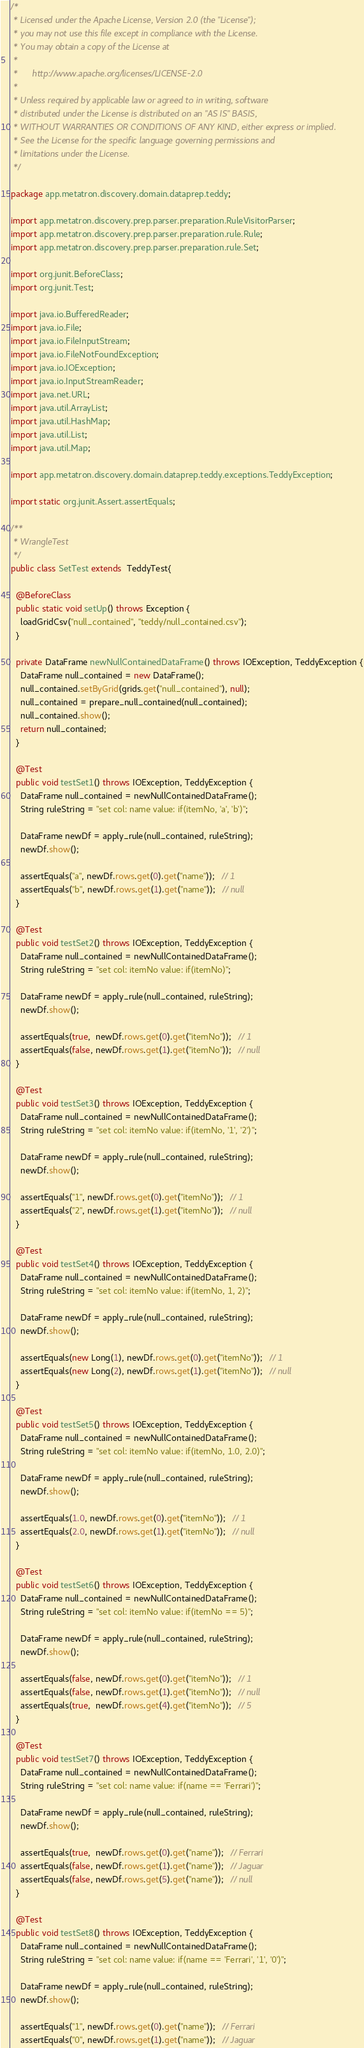Convert code to text. <code><loc_0><loc_0><loc_500><loc_500><_Java_>/*
 * Licensed under the Apache License, Version 2.0 (the "License");
 * you may not use this file except in compliance with the License.
 * You may obtain a copy of the License at
 *
 *      http://www.apache.org/licenses/LICENSE-2.0
 *
 * Unless required by applicable law or agreed to in writing, software
 * distributed under the License is distributed on an "AS IS" BASIS,
 * WITHOUT WARRANTIES OR CONDITIONS OF ANY KIND, either express or implied.
 * See the License for the specific language governing permissions and
 * limitations under the License.
 */

package app.metatron.discovery.domain.dataprep.teddy;

import app.metatron.discovery.prep.parser.preparation.RuleVisitorParser;
import app.metatron.discovery.prep.parser.preparation.rule.Rule;
import app.metatron.discovery.prep.parser.preparation.rule.Set;

import org.junit.BeforeClass;
import org.junit.Test;

import java.io.BufferedReader;
import java.io.File;
import java.io.FileInputStream;
import java.io.FileNotFoundException;
import java.io.IOException;
import java.io.InputStreamReader;
import java.net.URL;
import java.util.ArrayList;
import java.util.HashMap;
import java.util.List;
import java.util.Map;

import app.metatron.discovery.domain.dataprep.teddy.exceptions.TeddyException;

import static org.junit.Assert.assertEquals;

/**
 * WrangleTest
 */
public class SetTest extends  TeddyTest{
  
  @BeforeClass
  public static void setUp() throws Exception {
    loadGridCsv("null_contained", "teddy/null_contained.csv");
  }

  private DataFrame newNullContainedDataFrame() throws IOException, TeddyException {
    DataFrame null_contained = new DataFrame();
    null_contained.setByGrid(grids.get("null_contained"), null);
    null_contained = prepare_null_contained(null_contained);
    null_contained.show();
    return null_contained;
  }

  @Test
  public void testSet1() throws IOException, TeddyException {
    DataFrame null_contained = newNullContainedDataFrame();
    String ruleString = "set col: name value: if(itemNo, 'a', 'b')";
    
    DataFrame newDf = apply_rule(null_contained, ruleString);
    newDf.show();

    assertEquals("a", newDf.rows.get(0).get("name"));   // 1
    assertEquals("b", newDf.rows.get(1).get("name"));   // null
  }

  @Test
  public void testSet2() throws IOException, TeddyException {
    DataFrame null_contained = newNullContainedDataFrame();
    String ruleString = "set col: itemNo value: if(itemNo)";
    
    DataFrame newDf = apply_rule(null_contained, ruleString);
    newDf.show();

    assertEquals(true,  newDf.rows.get(0).get("itemNo"));   // 1
    assertEquals(false, newDf.rows.get(1).get("itemNo"));   // null
  }

  @Test
  public void testSet3() throws IOException, TeddyException {
    DataFrame null_contained = newNullContainedDataFrame();
    String ruleString = "set col: itemNo value: if(itemNo, '1', '2')";
    
    DataFrame newDf = apply_rule(null_contained, ruleString);
    newDf.show();

    assertEquals("1", newDf.rows.get(0).get("itemNo"));   // 1
    assertEquals("2", newDf.rows.get(1).get("itemNo"));   // null
  }

  @Test
  public void testSet4() throws IOException, TeddyException {
    DataFrame null_contained = newNullContainedDataFrame();
    String ruleString = "set col: itemNo value: if(itemNo, 1, 2)";
    
    DataFrame newDf = apply_rule(null_contained, ruleString);
    newDf.show();

    assertEquals(new Long(1), newDf.rows.get(0).get("itemNo"));   // 1
    assertEquals(new Long(2), newDf.rows.get(1).get("itemNo"));   // null
  }

  @Test
  public void testSet5() throws IOException, TeddyException {
    DataFrame null_contained = newNullContainedDataFrame();
    String ruleString = "set col: itemNo value: if(itemNo, 1.0, 2.0)";
    
    DataFrame newDf = apply_rule(null_contained, ruleString);
    newDf.show();

    assertEquals(1.0, newDf.rows.get(0).get("itemNo"));   // 1
    assertEquals(2.0, newDf.rows.get(1).get("itemNo"));   // null
  }

  @Test
  public void testSet6() throws IOException, TeddyException {
    DataFrame null_contained = newNullContainedDataFrame();
    String ruleString = "set col: itemNo value: if(itemNo == 5)";
    
    DataFrame newDf = apply_rule(null_contained, ruleString);
    newDf.show();

    assertEquals(false, newDf.rows.get(0).get("itemNo"));   // 1
    assertEquals(false, newDf.rows.get(1).get("itemNo"));   // null
    assertEquals(true,  newDf.rows.get(4).get("itemNo"));   // 5
  }

  @Test
  public void testSet7() throws IOException, TeddyException {
    DataFrame null_contained = newNullContainedDataFrame();
    String ruleString = "set col: name value: if(name == 'Ferrari')";
    
    DataFrame newDf = apply_rule(null_contained, ruleString);
    newDf.show();

    assertEquals(true,  newDf.rows.get(0).get("name"));   // Ferrari
    assertEquals(false, newDf.rows.get(1).get("name"));   // Jaguar
    assertEquals(false, newDf.rows.get(5).get("name"));   // null
  }

  @Test
  public void testSet8() throws IOException, TeddyException {
    DataFrame null_contained = newNullContainedDataFrame();
    String ruleString = "set col: name value: if(name == 'Ferrari', '1', '0')";
    
    DataFrame newDf = apply_rule(null_contained, ruleString);
    newDf.show();

    assertEquals("1", newDf.rows.get(0).get("name"));   // Ferrari
    assertEquals("0", newDf.rows.get(1).get("name"));   // Jaguar</code> 